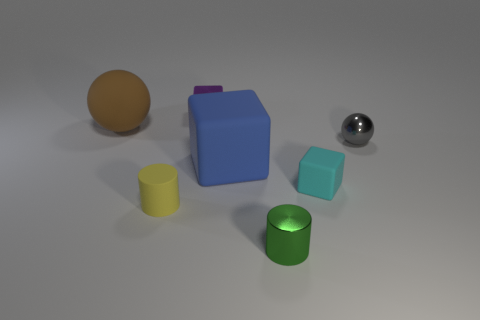What material is the small block that is behind the object to the left of the yellow matte cylinder?
Your response must be concise. Metal. The green object has what size?
Give a very brief answer. Small. The sphere that is made of the same material as the small cyan thing is what size?
Make the answer very short. Large. Is the size of the metallic object to the left of the blue block the same as the blue block?
Provide a short and direct response. No. The small rubber thing to the right of the rubber cube that is behind the rubber cube that is to the right of the small metallic cylinder is what shape?
Your answer should be compact. Cube. How many objects are small purple objects or cubes behind the tiny gray metallic ball?
Your response must be concise. 1. What size is the purple shiny cube that is behind the small rubber cylinder?
Provide a succinct answer. Small. Are the small purple thing and the tiny block that is in front of the matte ball made of the same material?
Keep it short and to the point. No. There is a cylinder that is to the right of the rubber cube left of the small cyan rubber thing; what number of large matte balls are behind it?
Ensure brevity in your answer.  1. How many gray things are tiny shiny cylinders or tiny shiny balls?
Make the answer very short. 1. 